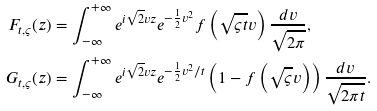<formula> <loc_0><loc_0><loc_500><loc_500>F _ { t , \varsigma } ( z ) & = \int _ { - \infty } ^ { + \infty } e ^ { i \sqrt { 2 } v z } e ^ { - \frac { 1 } { 2 } v ^ { 2 } } f \left ( \sqrt { \varsigma t } v \right ) \frac { d v } { \sqrt { 2 \pi } } , \\ G _ { t , \varsigma } ( z ) & = \int _ { - \infty } ^ { + \infty } e ^ { i \sqrt { 2 } v z } e ^ { - \frac { 1 } { 2 } v ^ { 2 } / t } \left ( 1 - f \left ( \sqrt { \varsigma } v \right ) \right ) \frac { d v } { \sqrt { 2 \pi t } } . \\</formula> 